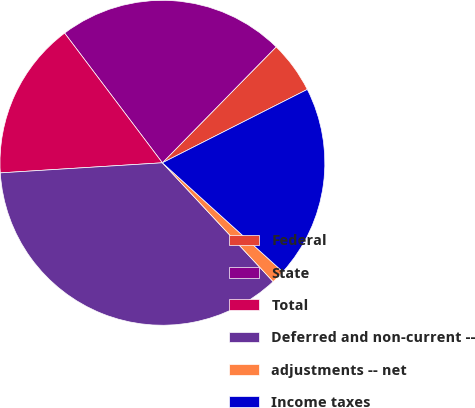<chart> <loc_0><loc_0><loc_500><loc_500><pie_chart><fcel>Federal<fcel>State<fcel>Total<fcel>Deferred and non-current --<fcel>adjustments -- net<fcel>Income taxes<nl><fcel>5.19%<fcel>22.63%<fcel>15.71%<fcel>35.95%<fcel>1.35%<fcel>19.17%<nl></chart> 